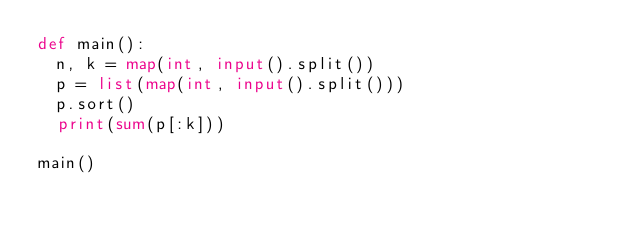<code> <loc_0><loc_0><loc_500><loc_500><_Python_>def main():
  n, k = map(int, input().split())
  p = list(map(int, input().split()))
  p.sort()
  print(sum(p[:k]))

main()
</code> 